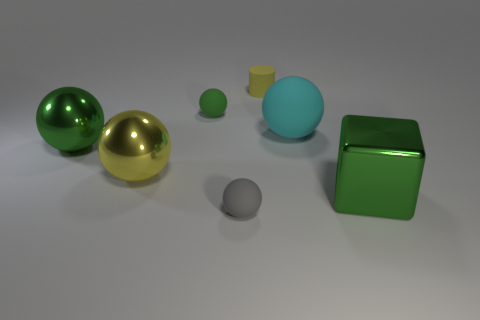Subtract all yellow balls. How many balls are left? 4 Subtract all gray spheres. How many spheres are left? 4 Subtract 0 purple cubes. How many objects are left? 7 Subtract all balls. How many objects are left? 2 Subtract 1 cubes. How many cubes are left? 0 Subtract all cyan spheres. Subtract all yellow cylinders. How many spheres are left? 4 Subtract all yellow cubes. How many cyan balls are left? 1 Subtract all small brown matte spheres. Subtract all tiny spheres. How many objects are left? 5 Add 5 gray rubber balls. How many gray rubber balls are left? 6 Add 1 small blue shiny cylinders. How many small blue shiny cylinders exist? 1 